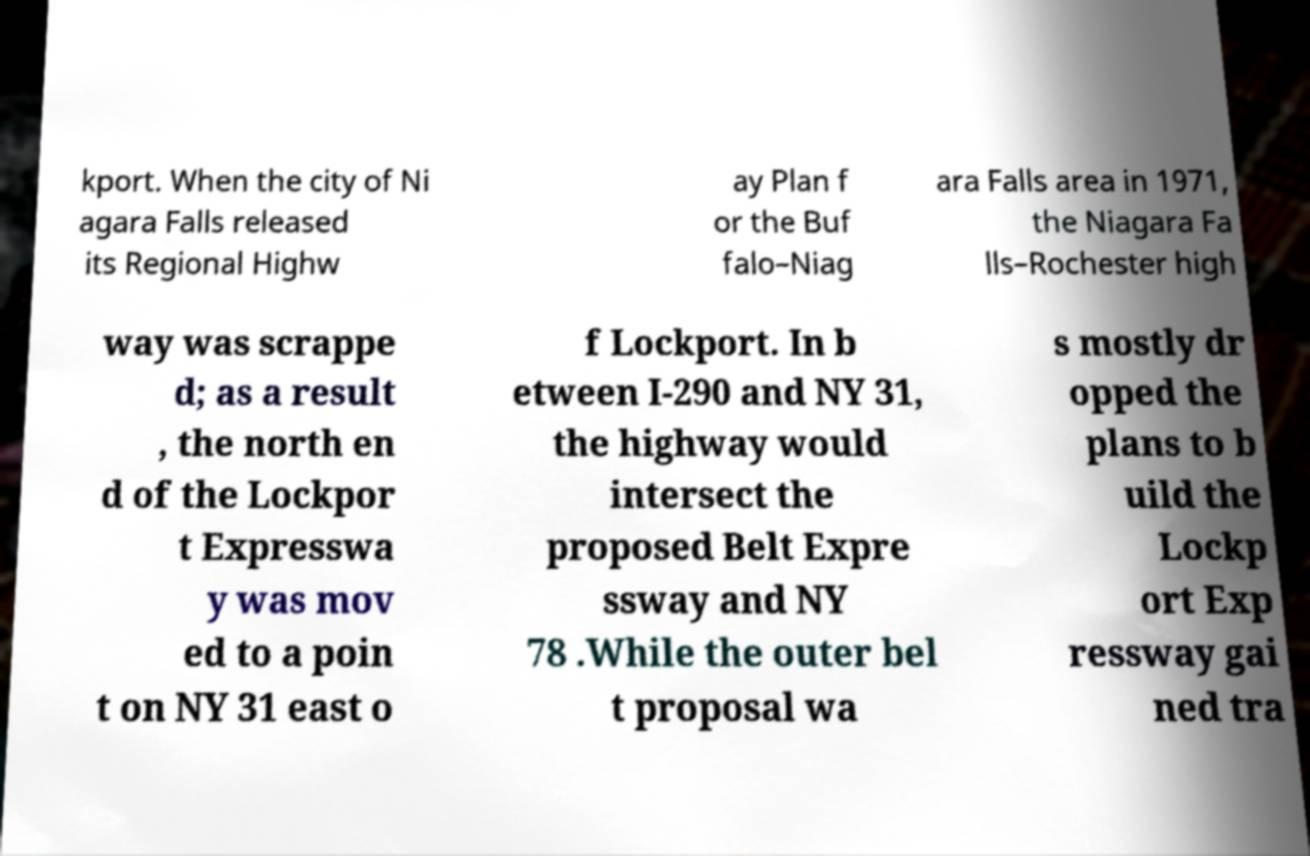I need the written content from this picture converted into text. Can you do that? kport. When the city of Ni agara Falls released its Regional Highw ay Plan f or the Buf falo–Niag ara Falls area in 1971, the Niagara Fa lls–Rochester high way was scrappe d; as a result , the north en d of the Lockpor t Expresswa y was mov ed to a poin t on NY 31 east o f Lockport. In b etween I-290 and NY 31, the highway would intersect the proposed Belt Expre ssway and NY 78 .While the outer bel t proposal wa s mostly dr opped the plans to b uild the Lockp ort Exp ressway gai ned tra 